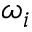Convert formula to latex. <formula><loc_0><loc_0><loc_500><loc_500>\omega _ { i }</formula> 